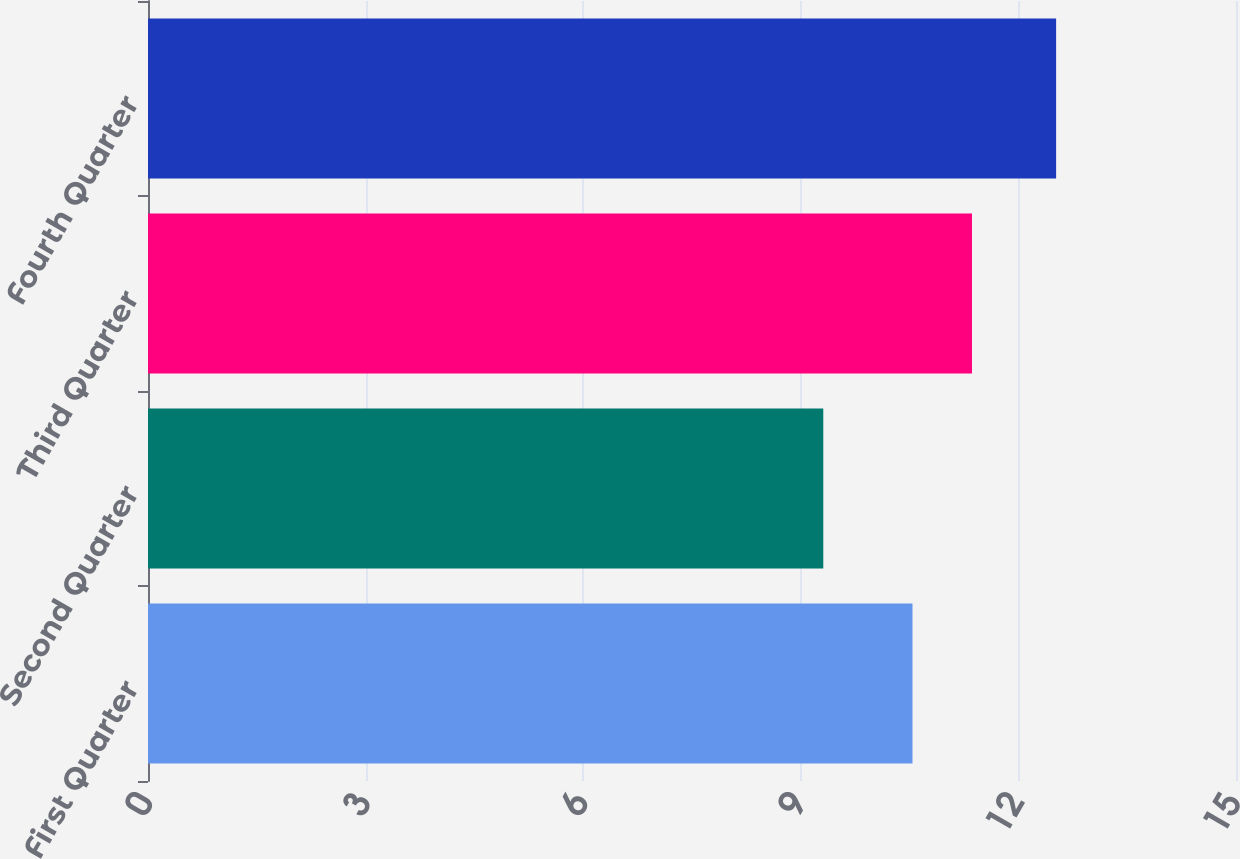Convert chart. <chart><loc_0><loc_0><loc_500><loc_500><bar_chart><fcel>First Quarter<fcel>Second Quarter<fcel>Third Quarter<fcel>Fourth Quarter<nl><fcel>10.54<fcel>9.31<fcel>11.36<fcel>12.52<nl></chart> 